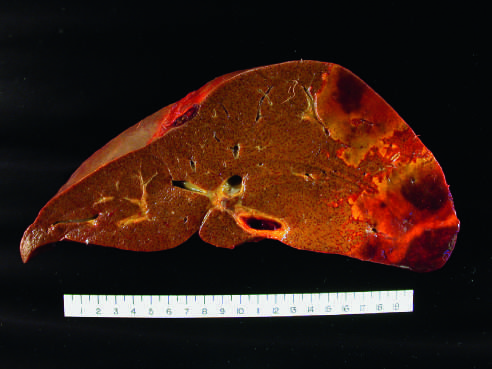s the distal hepatic tissue pale, with a hemorrhagic margin?
Answer the question using a single word or phrase. Yes 